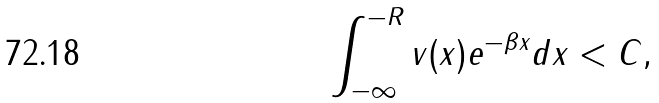Convert formula to latex. <formula><loc_0><loc_0><loc_500><loc_500>\int _ { - \infty } ^ { - R } v ( x ) e ^ { - \beta x } d x < C ,</formula> 